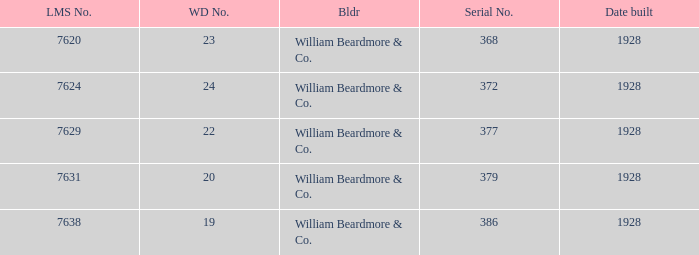Could you parse the entire table? {'header': ['LMS No.', 'WD No.', 'Bldr', 'Serial No.', 'Date built'], 'rows': [['7620', '23', 'William Beardmore & Co.', '368', '1928'], ['7624', '24', 'William Beardmore & Co.', '372', '1928'], ['7629', '22', 'William Beardmore & Co.', '377', '1928'], ['7631', '20', 'William Beardmore & Co.', '379', '1928'], ['7638', '19', 'William Beardmore & Co.', '386', '1928']]} Name the builder for serial number being 377 William Beardmore & Co. 